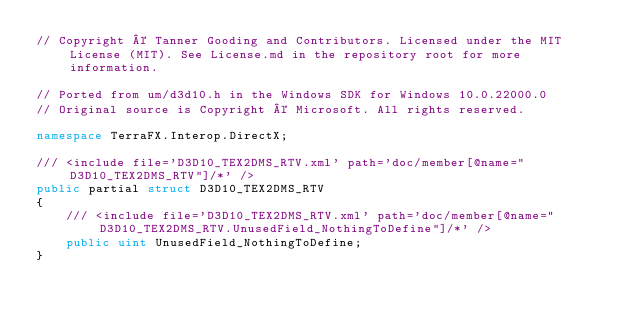<code> <loc_0><loc_0><loc_500><loc_500><_C#_>// Copyright © Tanner Gooding and Contributors. Licensed under the MIT License (MIT). See License.md in the repository root for more information.

// Ported from um/d3d10.h in the Windows SDK for Windows 10.0.22000.0
// Original source is Copyright © Microsoft. All rights reserved.

namespace TerraFX.Interop.DirectX;

/// <include file='D3D10_TEX2DMS_RTV.xml' path='doc/member[@name="D3D10_TEX2DMS_RTV"]/*' />
public partial struct D3D10_TEX2DMS_RTV
{
    /// <include file='D3D10_TEX2DMS_RTV.xml' path='doc/member[@name="D3D10_TEX2DMS_RTV.UnusedField_NothingToDefine"]/*' />
    public uint UnusedField_NothingToDefine;
}
</code> 